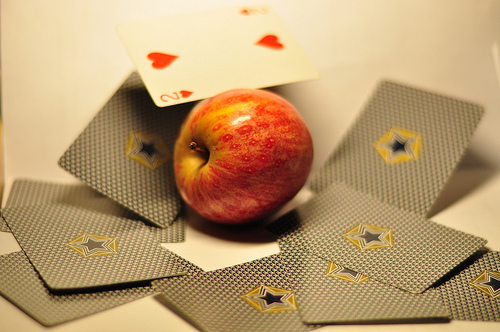<image>
Is there a cards next to the apple? Yes. The cards is positioned adjacent to the apple, located nearby in the same general area. Is the card under the apple? No. The card is not positioned under the apple. The vertical relationship between these objects is different. Is there a apple in the playing cards? Yes. The apple is contained within or inside the playing cards, showing a containment relationship. 